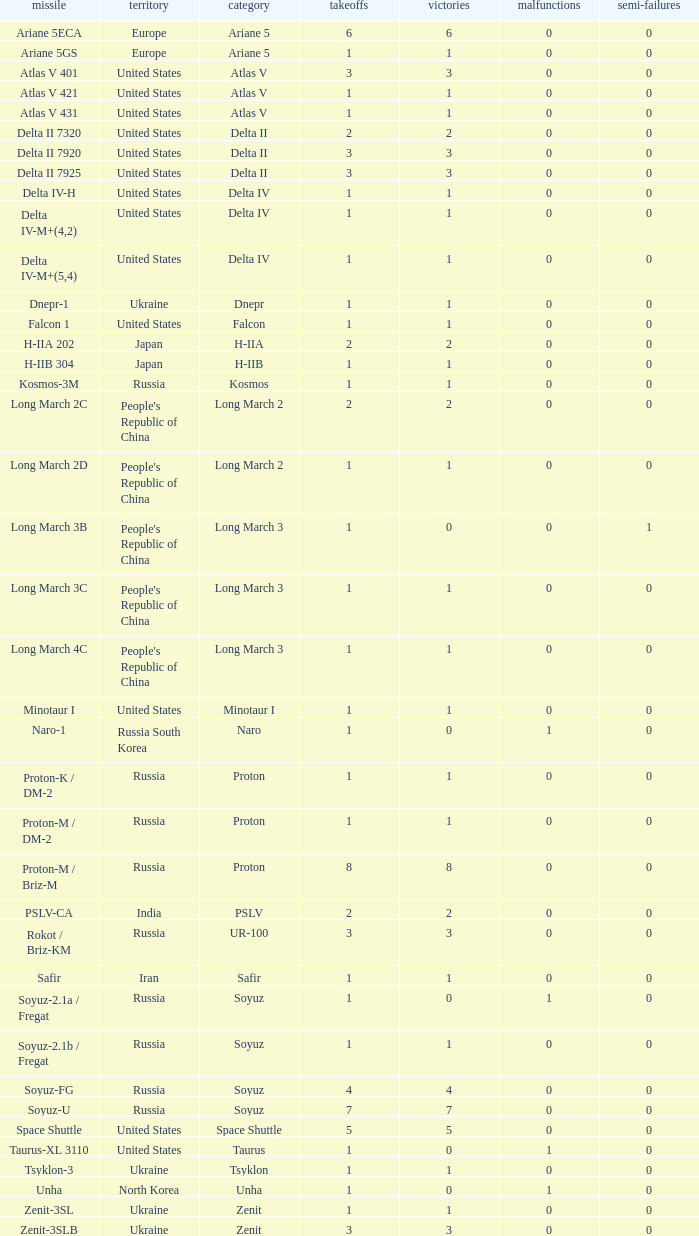What's the total failures among rockets that had more than 3 successes, type ariane 5 and more than 0 partial failures? 0.0. 